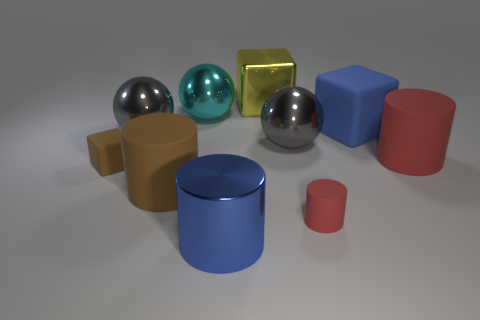Subtract all green blocks. How many gray balls are left? 2 Subtract all gray shiny balls. How many balls are left? 1 Subtract 1 blocks. How many blocks are left? 2 Subtract all blue cylinders. How many cylinders are left? 3 Subtract all red balls. Subtract all cyan cylinders. How many balls are left? 3 Subtract 0 purple cylinders. How many objects are left? 10 Subtract all cylinders. How many objects are left? 6 Subtract all large metallic cylinders. Subtract all large cyan metallic balls. How many objects are left? 8 Add 7 spheres. How many spheres are left? 10 Add 5 brown matte balls. How many brown matte balls exist? 5 